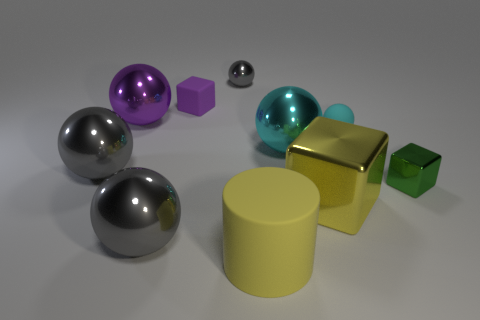How many large cyan objects have the same shape as the large purple shiny object?
Keep it short and to the point. 1. There is a small green thing; does it have the same shape as the cyan thing that is left of the large metal cube?
Your answer should be very brief. No. The object that is the same color as the big block is what shape?
Your answer should be compact. Cylinder. Is there a purple sphere made of the same material as the small gray ball?
Ensure brevity in your answer.  Yes. Is there any other thing that has the same material as the tiny gray object?
Your answer should be very brief. Yes. The tiny object that is to the left of the gray ball that is behind the small purple rubber thing is made of what material?
Your answer should be compact. Rubber. What size is the thing that is behind the cube that is behind the tiny shiny thing that is right of the small metal sphere?
Your response must be concise. Small. What number of other things are there of the same shape as the yellow matte object?
Ensure brevity in your answer.  0. There is a matte object in front of the green thing; is its color the same as the tiny shiny object in front of the purple shiny ball?
Ensure brevity in your answer.  No. There is a metal sphere that is the same size as the matte sphere; what is its color?
Give a very brief answer. Gray. 